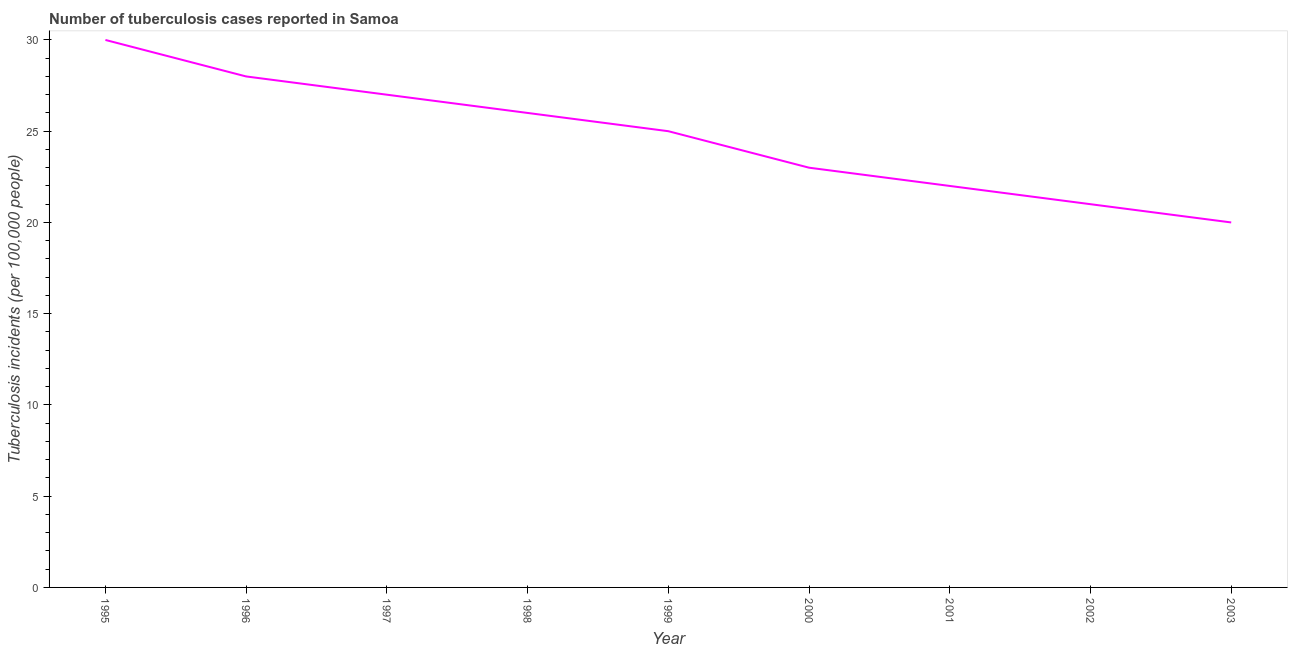What is the number of tuberculosis incidents in 2001?
Your answer should be compact. 22. Across all years, what is the maximum number of tuberculosis incidents?
Your answer should be very brief. 30. Across all years, what is the minimum number of tuberculosis incidents?
Offer a very short reply. 20. In which year was the number of tuberculosis incidents maximum?
Give a very brief answer. 1995. In which year was the number of tuberculosis incidents minimum?
Offer a terse response. 2003. What is the sum of the number of tuberculosis incidents?
Offer a terse response. 222. What is the difference between the number of tuberculosis incidents in 1996 and 1999?
Your answer should be very brief. 3. What is the average number of tuberculosis incidents per year?
Your answer should be very brief. 24.67. In how many years, is the number of tuberculosis incidents greater than 28 ?
Provide a short and direct response. 1. What is the ratio of the number of tuberculosis incidents in 1995 to that in 1997?
Offer a terse response. 1.11. Is the difference between the number of tuberculosis incidents in 1997 and 2000 greater than the difference between any two years?
Make the answer very short. No. Is the sum of the number of tuberculosis incidents in 1995 and 1996 greater than the maximum number of tuberculosis incidents across all years?
Make the answer very short. Yes. What is the difference between the highest and the lowest number of tuberculosis incidents?
Your answer should be compact. 10. In how many years, is the number of tuberculosis incidents greater than the average number of tuberculosis incidents taken over all years?
Provide a short and direct response. 5. How many lines are there?
Ensure brevity in your answer.  1. How many years are there in the graph?
Offer a terse response. 9. Are the values on the major ticks of Y-axis written in scientific E-notation?
Give a very brief answer. No. Does the graph contain any zero values?
Provide a succinct answer. No. What is the title of the graph?
Provide a short and direct response. Number of tuberculosis cases reported in Samoa. What is the label or title of the Y-axis?
Your response must be concise. Tuberculosis incidents (per 100,0 people). What is the Tuberculosis incidents (per 100,000 people) of 1995?
Offer a terse response. 30. What is the Tuberculosis incidents (per 100,000 people) of 1997?
Ensure brevity in your answer.  27. What is the Tuberculosis incidents (per 100,000 people) of 2000?
Offer a very short reply. 23. What is the difference between the Tuberculosis incidents (per 100,000 people) in 1995 and 2003?
Ensure brevity in your answer.  10. What is the difference between the Tuberculosis incidents (per 100,000 people) in 1996 and 1997?
Your answer should be compact. 1. What is the difference between the Tuberculosis incidents (per 100,000 people) in 1996 and 2000?
Make the answer very short. 5. What is the difference between the Tuberculosis incidents (per 100,000 people) in 1996 and 2002?
Your answer should be very brief. 7. What is the difference between the Tuberculosis incidents (per 100,000 people) in 1997 and 1998?
Your answer should be compact. 1. What is the difference between the Tuberculosis incidents (per 100,000 people) in 1997 and 1999?
Keep it short and to the point. 2. What is the difference between the Tuberculosis incidents (per 100,000 people) in 1998 and 2000?
Provide a succinct answer. 3. What is the difference between the Tuberculosis incidents (per 100,000 people) in 1998 and 2001?
Make the answer very short. 4. What is the difference between the Tuberculosis incidents (per 100,000 people) in 1998 and 2002?
Offer a very short reply. 5. What is the difference between the Tuberculosis incidents (per 100,000 people) in 1999 and 2000?
Your answer should be compact. 2. What is the difference between the Tuberculosis incidents (per 100,000 people) in 1999 and 2001?
Your answer should be very brief. 3. What is the difference between the Tuberculosis incidents (per 100,000 people) in 1999 and 2002?
Make the answer very short. 4. What is the difference between the Tuberculosis incidents (per 100,000 people) in 1999 and 2003?
Your answer should be very brief. 5. What is the difference between the Tuberculosis incidents (per 100,000 people) in 2000 and 2001?
Offer a very short reply. 1. What is the difference between the Tuberculosis incidents (per 100,000 people) in 2001 and 2002?
Offer a terse response. 1. What is the difference between the Tuberculosis incidents (per 100,000 people) in 2001 and 2003?
Provide a short and direct response. 2. What is the difference between the Tuberculosis incidents (per 100,000 people) in 2002 and 2003?
Give a very brief answer. 1. What is the ratio of the Tuberculosis incidents (per 100,000 people) in 1995 to that in 1996?
Make the answer very short. 1.07. What is the ratio of the Tuberculosis incidents (per 100,000 people) in 1995 to that in 1997?
Provide a short and direct response. 1.11. What is the ratio of the Tuberculosis incidents (per 100,000 people) in 1995 to that in 1998?
Make the answer very short. 1.15. What is the ratio of the Tuberculosis incidents (per 100,000 people) in 1995 to that in 2000?
Give a very brief answer. 1.3. What is the ratio of the Tuberculosis incidents (per 100,000 people) in 1995 to that in 2001?
Ensure brevity in your answer.  1.36. What is the ratio of the Tuberculosis incidents (per 100,000 people) in 1995 to that in 2002?
Offer a very short reply. 1.43. What is the ratio of the Tuberculosis incidents (per 100,000 people) in 1995 to that in 2003?
Make the answer very short. 1.5. What is the ratio of the Tuberculosis incidents (per 100,000 people) in 1996 to that in 1997?
Keep it short and to the point. 1.04. What is the ratio of the Tuberculosis incidents (per 100,000 people) in 1996 to that in 1998?
Provide a short and direct response. 1.08. What is the ratio of the Tuberculosis incidents (per 100,000 people) in 1996 to that in 1999?
Ensure brevity in your answer.  1.12. What is the ratio of the Tuberculosis incidents (per 100,000 people) in 1996 to that in 2000?
Keep it short and to the point. 1.22. What is the ratio of the Tuberculosis incidents (per 100,000 people) in 1996 to that in 2001?
Provide a short and direct response. 1.27. What is the ratio of the Tuberculosis incidents (per 100,000 people) in 1996 to that in 2002?
Provide a short and direct response. 1.33. What is the ratio of the Tuberculosis incidents (per 100,000 people) in 1996 to that in 2003?
Ensure brevity in your answer.  1.4. What is the ratio of the Tuberculosis incidents (per 100,000 people) in 1997 to that in 1998?
Offer a terse response. 1.04. What is the ratio of the Tuberculosis incidents (per 100,000 people) in 1997 to that in 1999?
Make the answer very short. 1.08. What is the ratio of the Tuberculosis incidents (per 100,000 people) in 1997 to that in 2000?
Provide a short and direct response. 1.17. What is the ratio of the Tuberculosis incidents (per 100,000 people) in 1997 to that in 2001?
Make the answer very short. 1.23. What is the ratio of the Tuberculosis incidents (per 100,000 people) in 1997 to that in 2002?
Your response must be concise. 1.29. What is the ratio of the Tuberculosis incidents (per 100,000 people) in 1997 to that in 2003?
Offer a very short reply. 1.35. What is the ratio of the Tuberculosis incidents (per 100,000 people) in 1998 to that in 2000?
Ensure brevity in your answer.  1.13. What is the ratio of the Tuberculosis incidents (per 100,000 people) in 1998 to that in 2001?
Your answer should be very brief. 1.18. What is the ratio of the Tuberculosis incidents (per 100,000 people) in 1998 to that in 2002?
Offer a terse response. 1.24. What is the ratio of the Tuberculosis incidents (per 100,000 people) in 1998 to that in 2003?
Offer a very short reply. 1.3. What is the ratio of the Tuberculosis incidents (per 100,000 people) in 1999 to that in 2000?
Give a very brief answer. 1.09. What is the ratio of the Tuberculosis incidents (per 100,000 people) in 1999 to that in 2001?
Offer a terse response. 1.14. What is the ratio of the Tuberculosis incidents (per 100,000 people) in 1999 to that in 2002?
Keep it short and to the point. 1.19. What is the ratio of the Tuberculosis incidents (per 100,000 people) in 2000 to that in 2001?
Your answer should be compact. 1.04. What is the ratio of the Tuberculosis incidents (per 100,000 people) in 2000 to that in 2002?
Offer a very short reply. 1.09. What is the ratio of the Tuberculosis incidents (per 100,000 people) in 2000 to that in 2003?
Provide a short and direct response. 1.15. What is the ratio of the Tuberculosis incidents (per 100,000 people) in 2001 to that in 2002?
Offer a terse response. 1.05. What is the ratio of the Tuberculosis incidents (per 100,000 people) in 2001 to that in 2003?
Your response must be concise. 1.1. What is the ratio of the Tuberculosis incidents (per 100,000 people) in 2002 to that in 2003?
Your answer should be very brief. 1.05. 